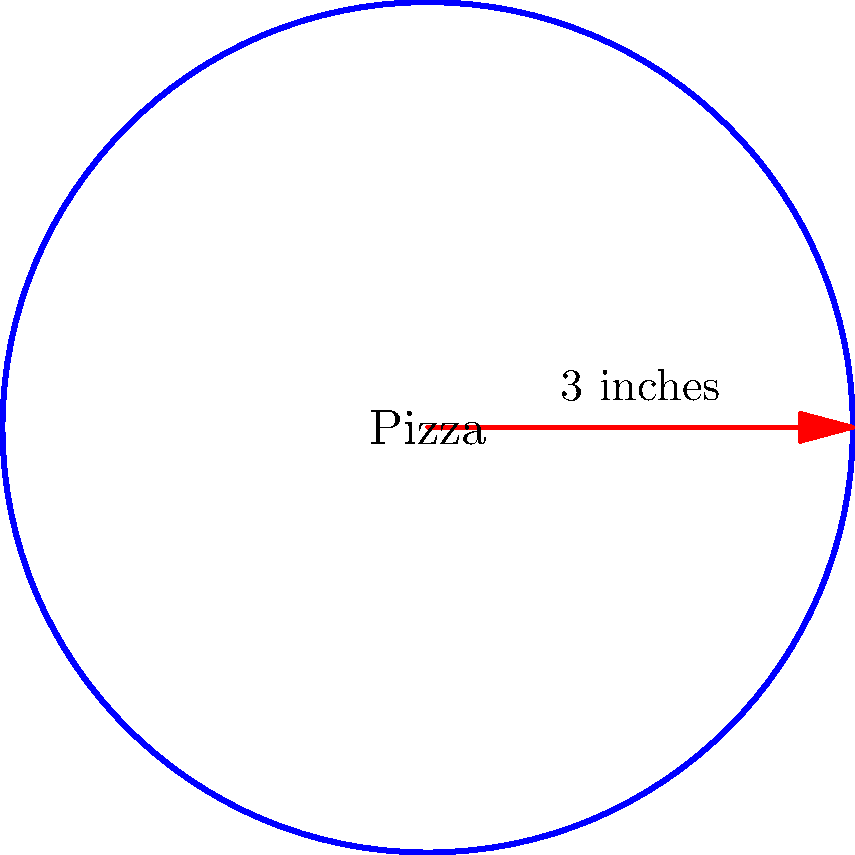You're planning a pizza party for your dorm floor. The local pizzeria offers a circular pizza with a radius of 3 inches. If you want to calculate the total area of toppings needed, what is the area of this pizza in square inches? (Use $\pi \approx 3.14$) Let's approach this step-by-step:

1) The formula for the area of a circle is $A = \pi r^2$, where $A$ is the area and $r$ is the radius.

2) We're given that the radius is 3 inches and we should use $\pi \approx 3.14$.

3) Let's plug these values into the formula:

   $A = \pi r^2$
   $A = 3.14 \times 3^2$

4) First, let's calculate $3^2$:
   $3^2 = 3 \times 3 = 9$

5) Now our equation looks like this:
   $A = 3.14 \times 9$

6) Multiplying these numbers:
   $A = 28.26$

Therefore, the area of the pizza is approximately 28.26 square inches.
Answer: $28.26$ square inches 